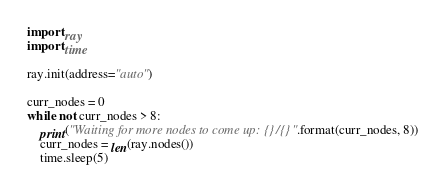Convert code to text. <code><loc_0><loc_0><loc_500><loc_500><_Python_>import ray
import time

ray.init(address="auto")

curr_nodes = 0
while not curr_nodes > 8:
    print("Waiting for more nodes to come up: {}/{}".format(curr_nodes, 8))
    curr_nodes = len(ray.nodes())
    time.sleep(5)
</code> 